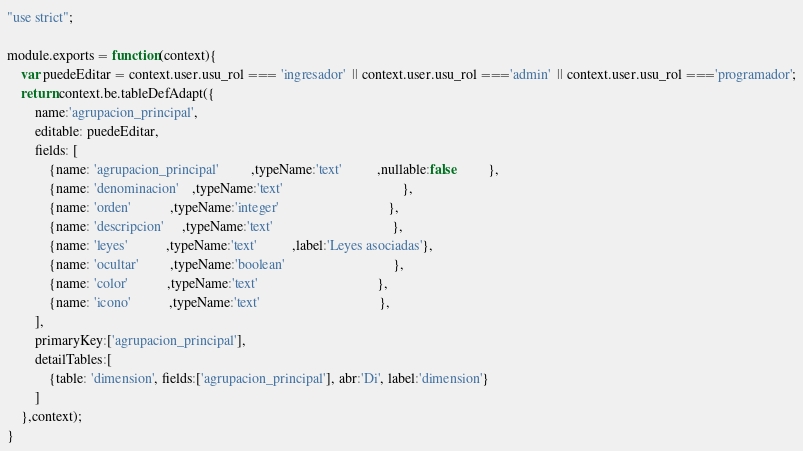Convert code to text. <code><loc_0><loc_0><loc_500><loc_500><_JavaScript_>"use strict";

module.exports = function(context){
    var puedeEditar = context.user.usu_rol === 'ingresador'  || context.user.usu_rol ==='admin'  || context.user.usu_rol ==='programador';
    return context.be.tableDefAdapt({
        name:'agrupacion_principal',
        editable: puedeEditar,
        fields: [
            {name: 'agrupacion_principal'         ,typeName:'text'          ,nullable:false         },
            {name: 'denominacion'    ,typeName:'text'                                  },
            {name: 'orden'           ,typeName:'integer'                               },
            {name: 'descripcion'     ,typeName:'text'                                  },
            {name: 'leyes'           ,typeName:'text'          ,label:'Leyes asociadas'},
            {name: 'ocultar'         ,typeName:'boolean'                               },
            {name: 'color'           ,typeName:'text'                                  },
            {name: 'icono'           ,typeName:'text'                                  },
        ],
        primaryKey:['agrupacion_principal'],
        detailTables:[
            {table: 'dimension', fields:['agrupacion_principal'], abr:'Di', label:'dimension'}
        ]
    },context);
}</code> 